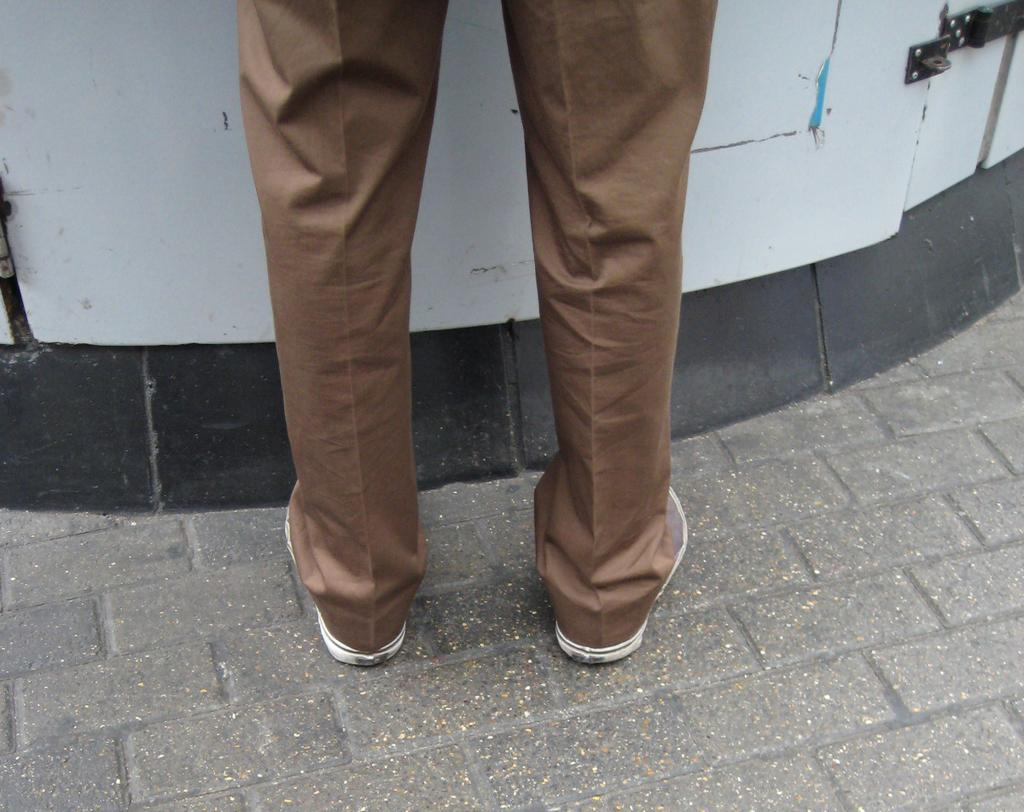What is present in the image? There is a person in the image. What part of the person's body can be seen? The person's legs are visible. What is the person standing on? The person is standing on the ground. What is in front of the person? There is a door in front of the person. What type of mint is growing near the person's feet in the image? There is no mint present in the image; it only features a person standing on the ground with a door in front of them. 